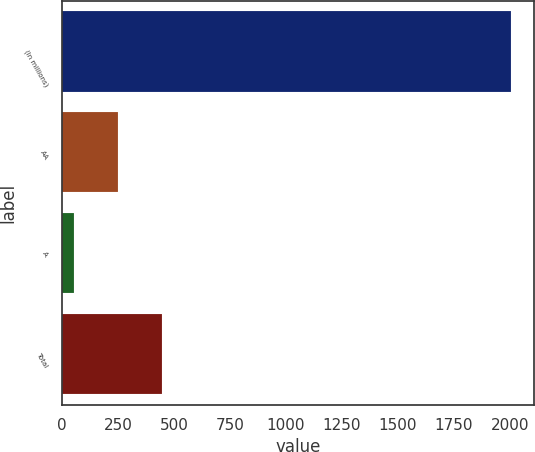Convert chart to OTSL. <chart><loc_0><loc_0><loc_500><loc_500><bar_chart><fcel>(In millions)<fcel>AA<fcel>A<fcel>Total<nl><fcel>2008<fcel>249.4<fcel>54<fcel>444.8<nl></chart> 